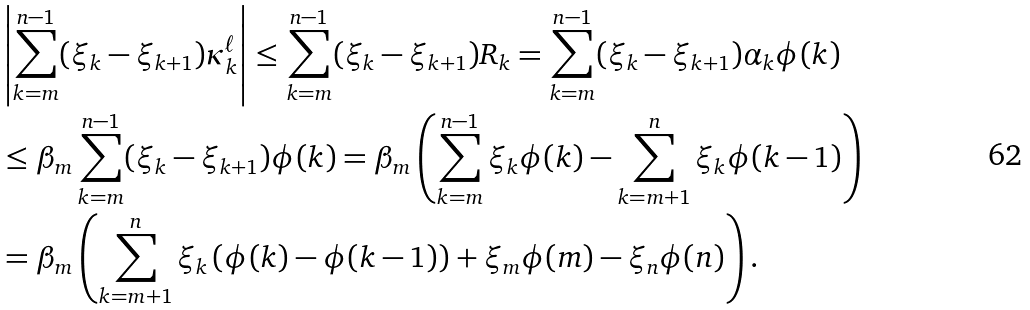Convert formula to latex. <formula><loc_0><loc_0><loc_500><loc_500>& \left | \sum _ { k = m } ^ { n - 1 } ( \xi _ { k } - \xi _ { k + 1 } ) \kappa _ { k } ^ { \ell } \right | \leq \sum _ { k = m } ^ { n - 1 } ( \xi _ { k } - \xi _ { k + 1 } ) R _ { k } = \sum _ { k = m } ^ { n - 1 } ( \xi _ { k } - \xi _ { k + 1 } ) \alpha _ { k } \phi ( k ) \\ & \leq \beta _ { m } \sum _ { k = m } ^ { n - 1 } ( \xi _ { k } - \xi _ { k + 1 } ) \phi ( k ) = \beta _ { m } \left ( \sum _ { k = m } ^ { n - 1 } \xi _ { k } \phi ( k ) - \sum _ { k = m + 1 } ^ { n } \xi _ { k } \phi ( k - 1 ) \right ) \\ & = \beta _ { m } \left ( \sum _ { k = m + 1 } ^ { n } \xi _ { k } \left ( \phi ( k ) - \phi ( k - 1 ) \right ) + \xi _ { m } \phi ( m ) - \xi _ { n } \phi ( n ) \right ) .</formula> 